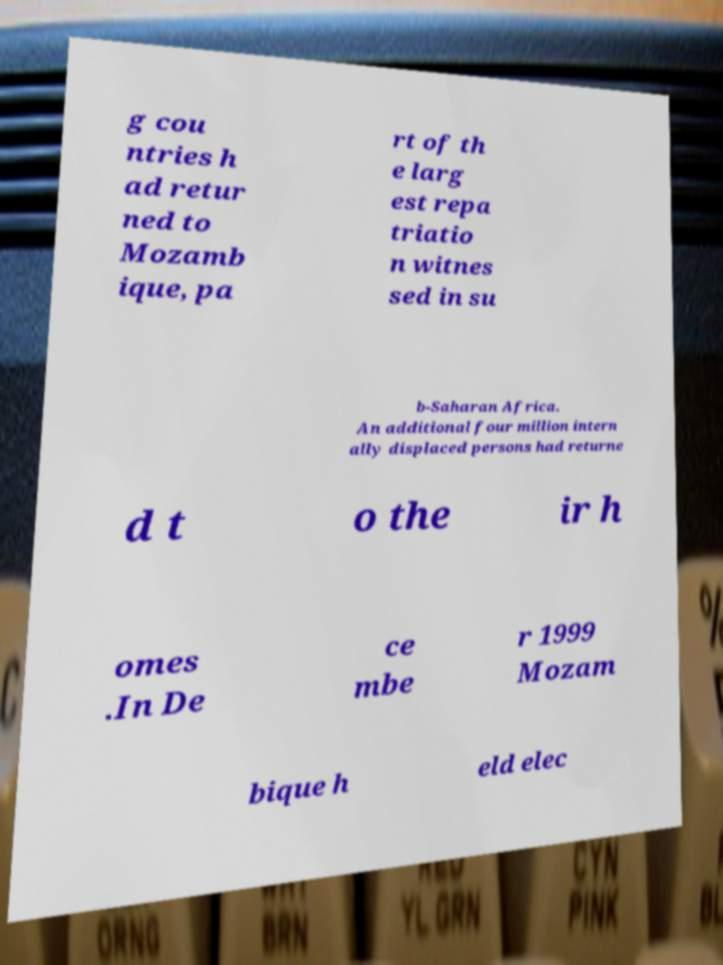I need the written content from this picture converted into text. Can you do that? g cou ntries h ad retur ned to Mozamb ique, pa rt of th e larg est repa triatio n witnes sed in su b-Saharan Africa. An additional four million intern ally displaced persons had returne d t o the ir h omes .In De ce mbe r 1999 Mozam bique h eld elec 